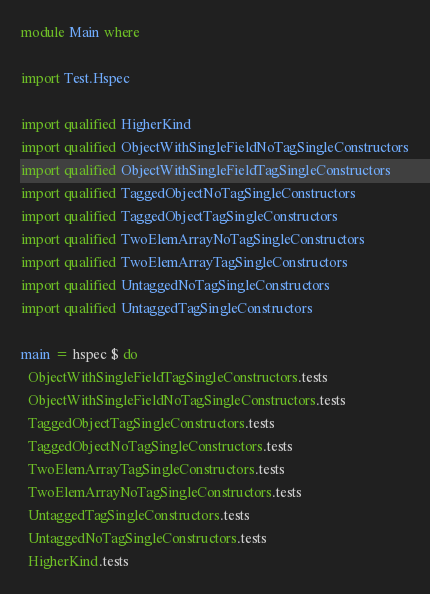<code> <loc_0><loc_0><loc_500><loc_500><_Haskell_>
module Main where

import Test.Hspec

import qualified HigherKind
import qualified ObjectWithSingleFieldNoTagSingleConstructors
import qualified ObjectWithSingleFieldTagSingleConstructors
import qualified TaggedObjectNoTagSingleConstructors
import qualified TaggedObjectTagSingleConstructors
import qualified TwoElemArrayNoTagSingleConstructors
import qualified TwoElemArrayTagSingleConstructors
import qualified UntaggedNoTagSingleConstructors
import qualified UntaggedTagSingleConstructors

main = hspec $ do
  ObjectWithSingleFieldTagSingleConstructors.tests
  ObjectWithSingleFieldNoTagSingleConstructors.tests
  TaggedObjectTagSingleConstructors.tests
  TaggedObjectNoTagSingleConstructors.tests
  TwoElemArrayTagSingleConstructors.tests
  TwoElemArrayNoTagSingleConstructors.tests
  UntaggedTagSingleConstructors.tests
  UntaggedNoTagSingleConstructors.tests
  HigherKind.tests
</code> 